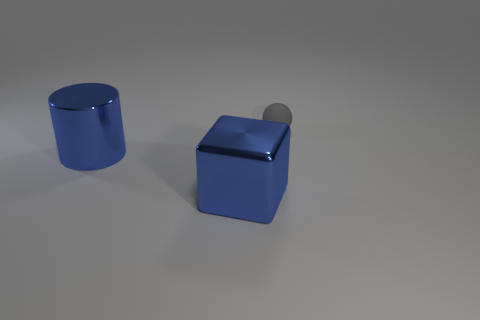Add 2 big blue shiny spheres. How many objects exist? 5 Subtract all blocks. How many objects are left? 2 Subtract all gray objects. Subtract all small gray spheres. How many objects are left? 1 Add 1 gray spheres. How many gray spheres are left? 2 Add 2 blue objects. How many blue objects exist? 4 Subtract 0 red cylinders. How many objects are left? 3 